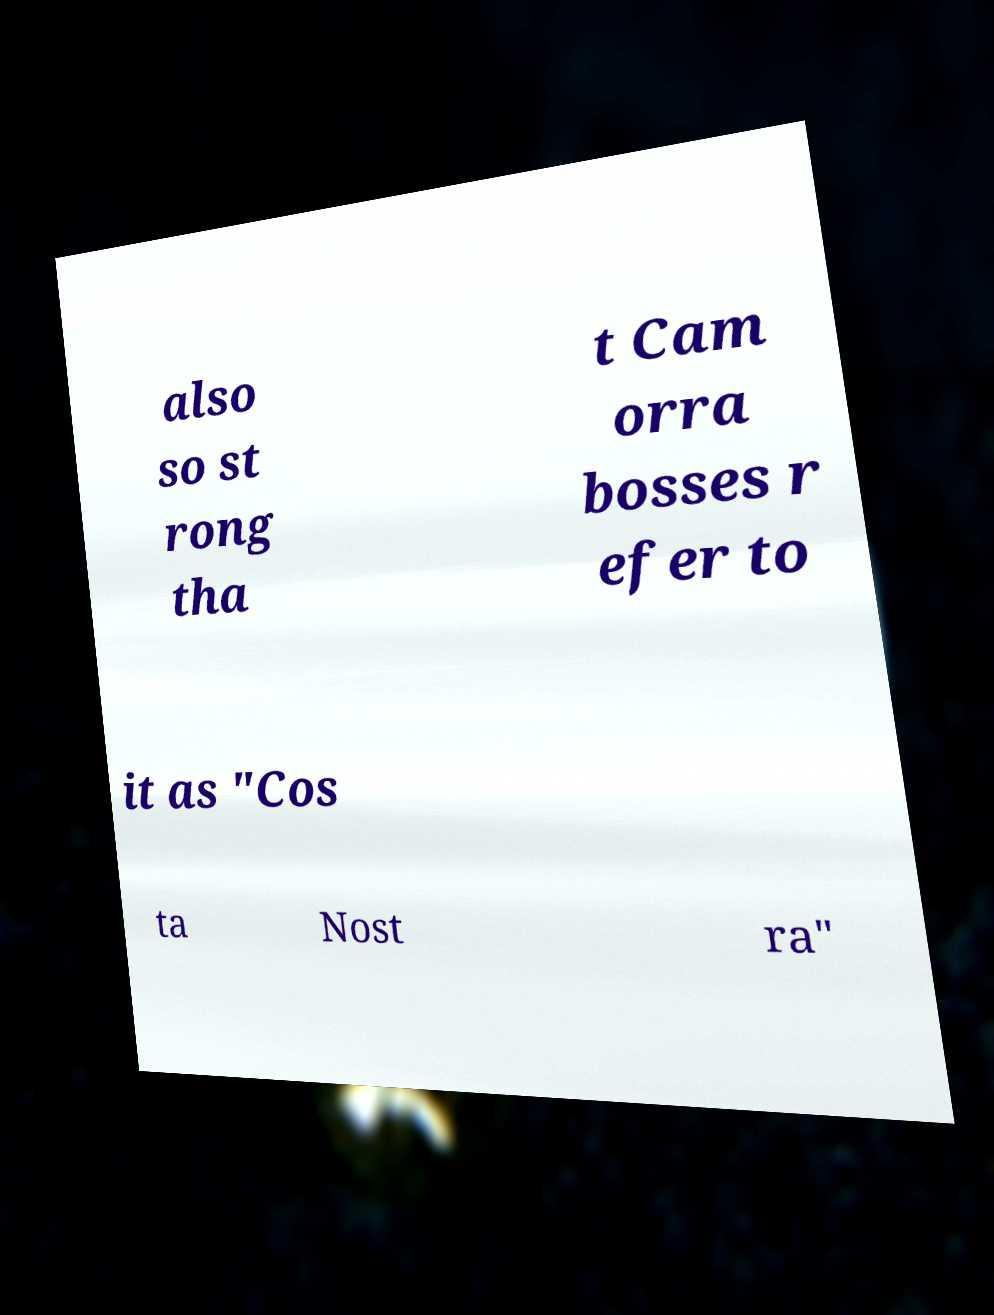Can you accurately transcribe the text from the provided image for me? also so st rong tha t Cam orra bosses r efer to it as "Cos ta Nost ra" 